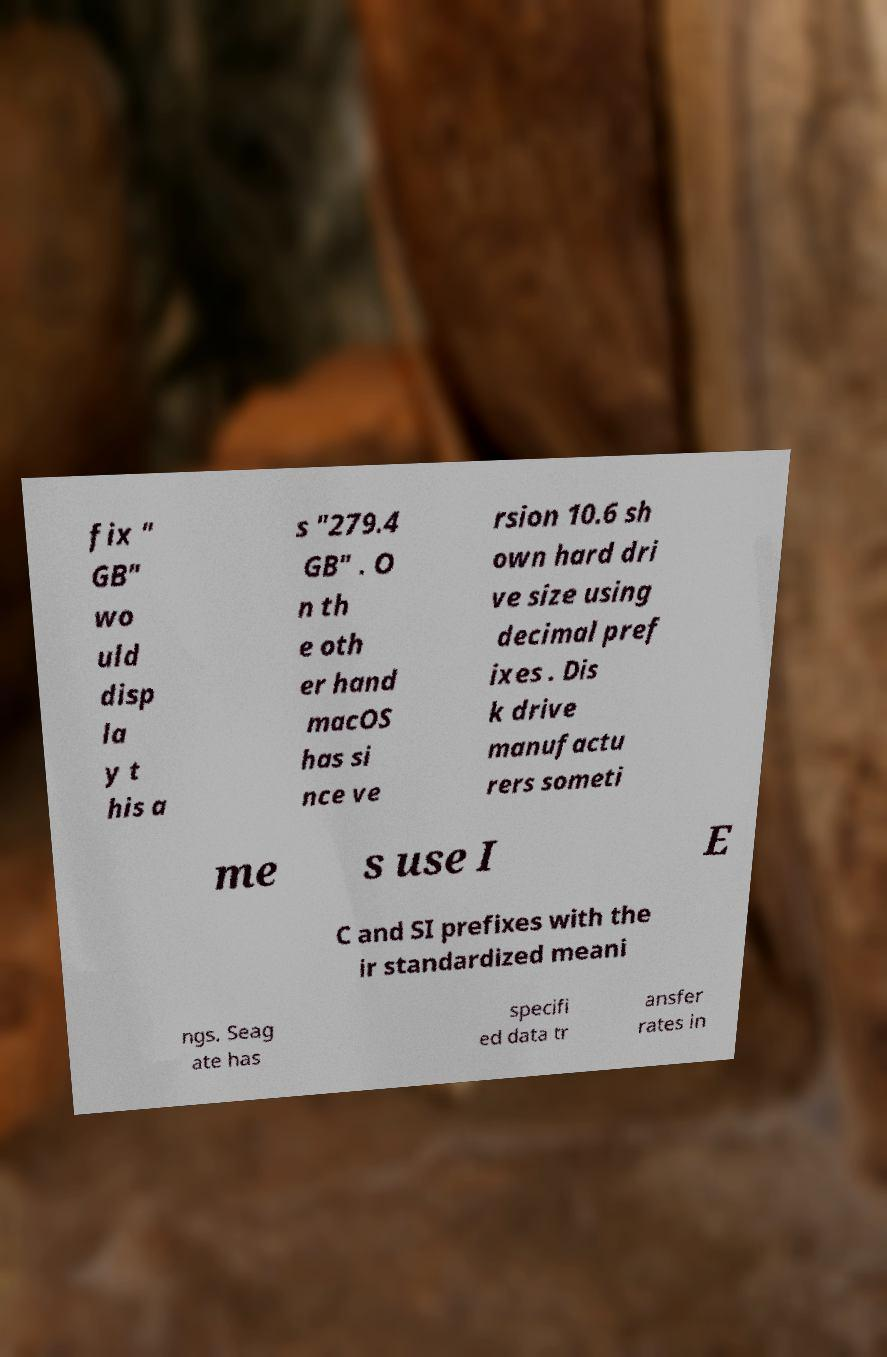Can you accurately transcribe the text from the provided image for me? fix " GB" wo uld disp la y t his a s "279.4 GB" . O n th e oth er hand macOS has si nce ve rsion 10.6 sh own hard dri ve size using decimal pref ixes . Dis k drive manufactu rers someti me s use I E C and SI prefixes with the ir standardized meani ngs. Seag ate has specifi ed data tr ansfer rates in 